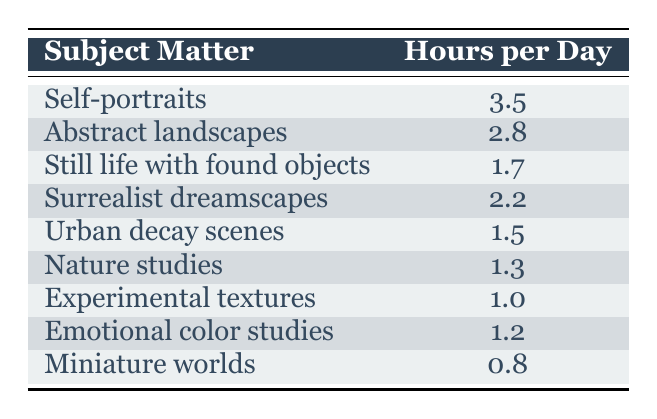What subject matter has the highest allocation of painting hours? Self-portraits have the highest allocation with 3.5 hours per day. This is directly visible in the table as the first row lists Self-portraits alongside the number of hours.
Answer: Self-portraits What is the total time allocated for painting Abstract landscapes and Surrealist dreamscapes? The time for Abstract landscapes is 2.8 hours and for Surrealist dreamscapes is 2.2 hours. Adding these two values together (2.8 + 2.2) gives a total of 5.0 hours.
Answer: 5.0 Is the time spent on Experimental textures greater than that on Nature studies? Experimental textures take 1.0 hour and Nature studies take 1.3 hours. Since 1.0 is less than 1.3, the answer is no.
Answer: No How many hours are spent on Urban decay scenes and Miniature worlds combined? Urban decay scenes take 1.5 hours and Miniature worlds take 0.8 hours. The combined total is calculated by adding both values (1.5 + 0.8), which equals 2.3 hours.
Answer: 2.3 What percentage of the total painting hours (all subjects combined) is devoted to Still life with found objects? To find the percentage, first calculate the total: 3.5 + 2.8 + 1.7 + 2.2 + 1.5 + 1.3 + 1.0 + 1.2 + 0.8 = 16.0 hours total. For Still life with found objects, it is 1.7 hours. We calculate the percentage as (1.7 / 16.0) * 100, which equals approximately 10.63%.
Answer: 10.63% 